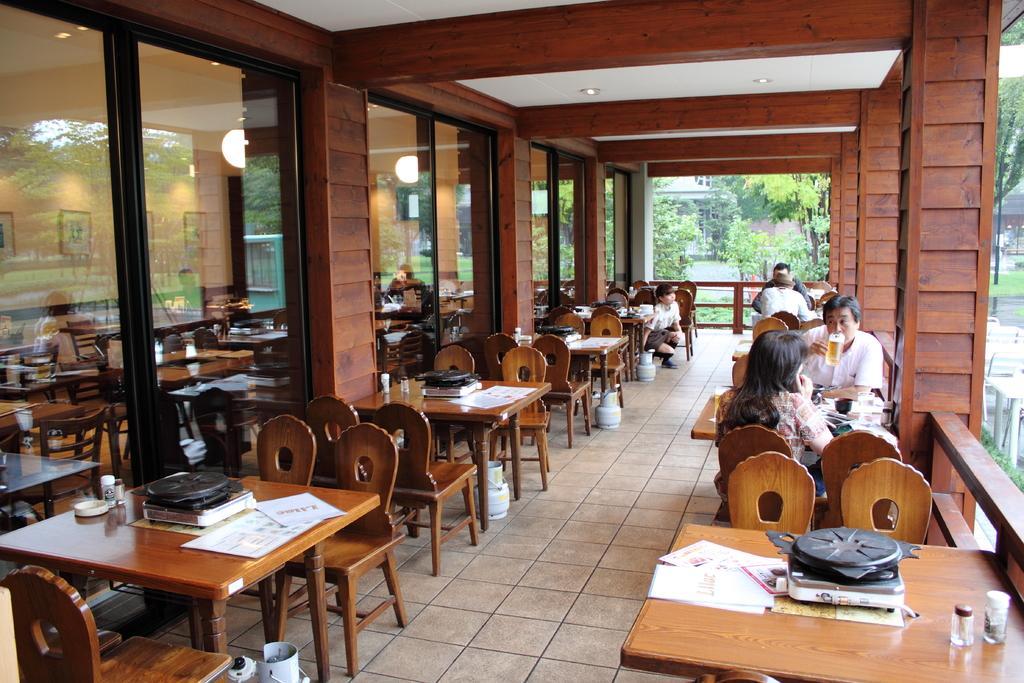Describe this image in one or two sentences. In this image I see number of chairs and tables on which there are few things and I see few people over here, who are sitting and this man is holding a glass in his hand. In the background I see the trees, pillars and lights over here. 